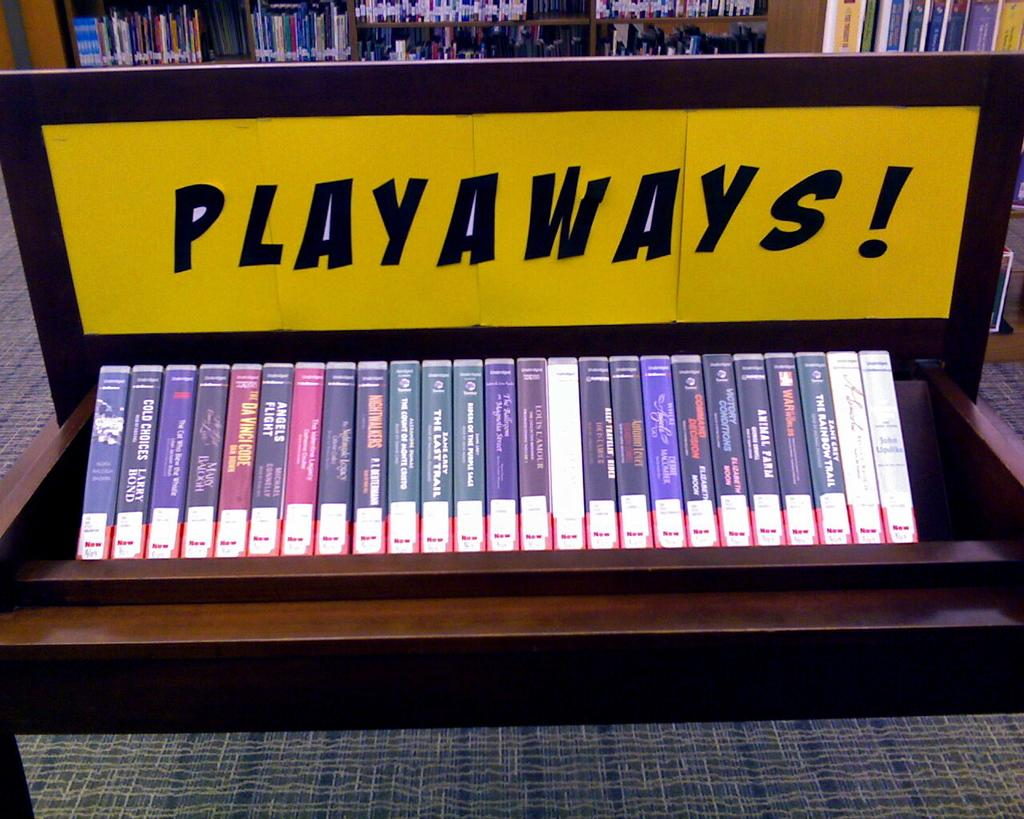<image>
Offer a succinct explanation of the picture presented. Promoting either books or videos is a yellow sign that reads PLAYAWAYS! 